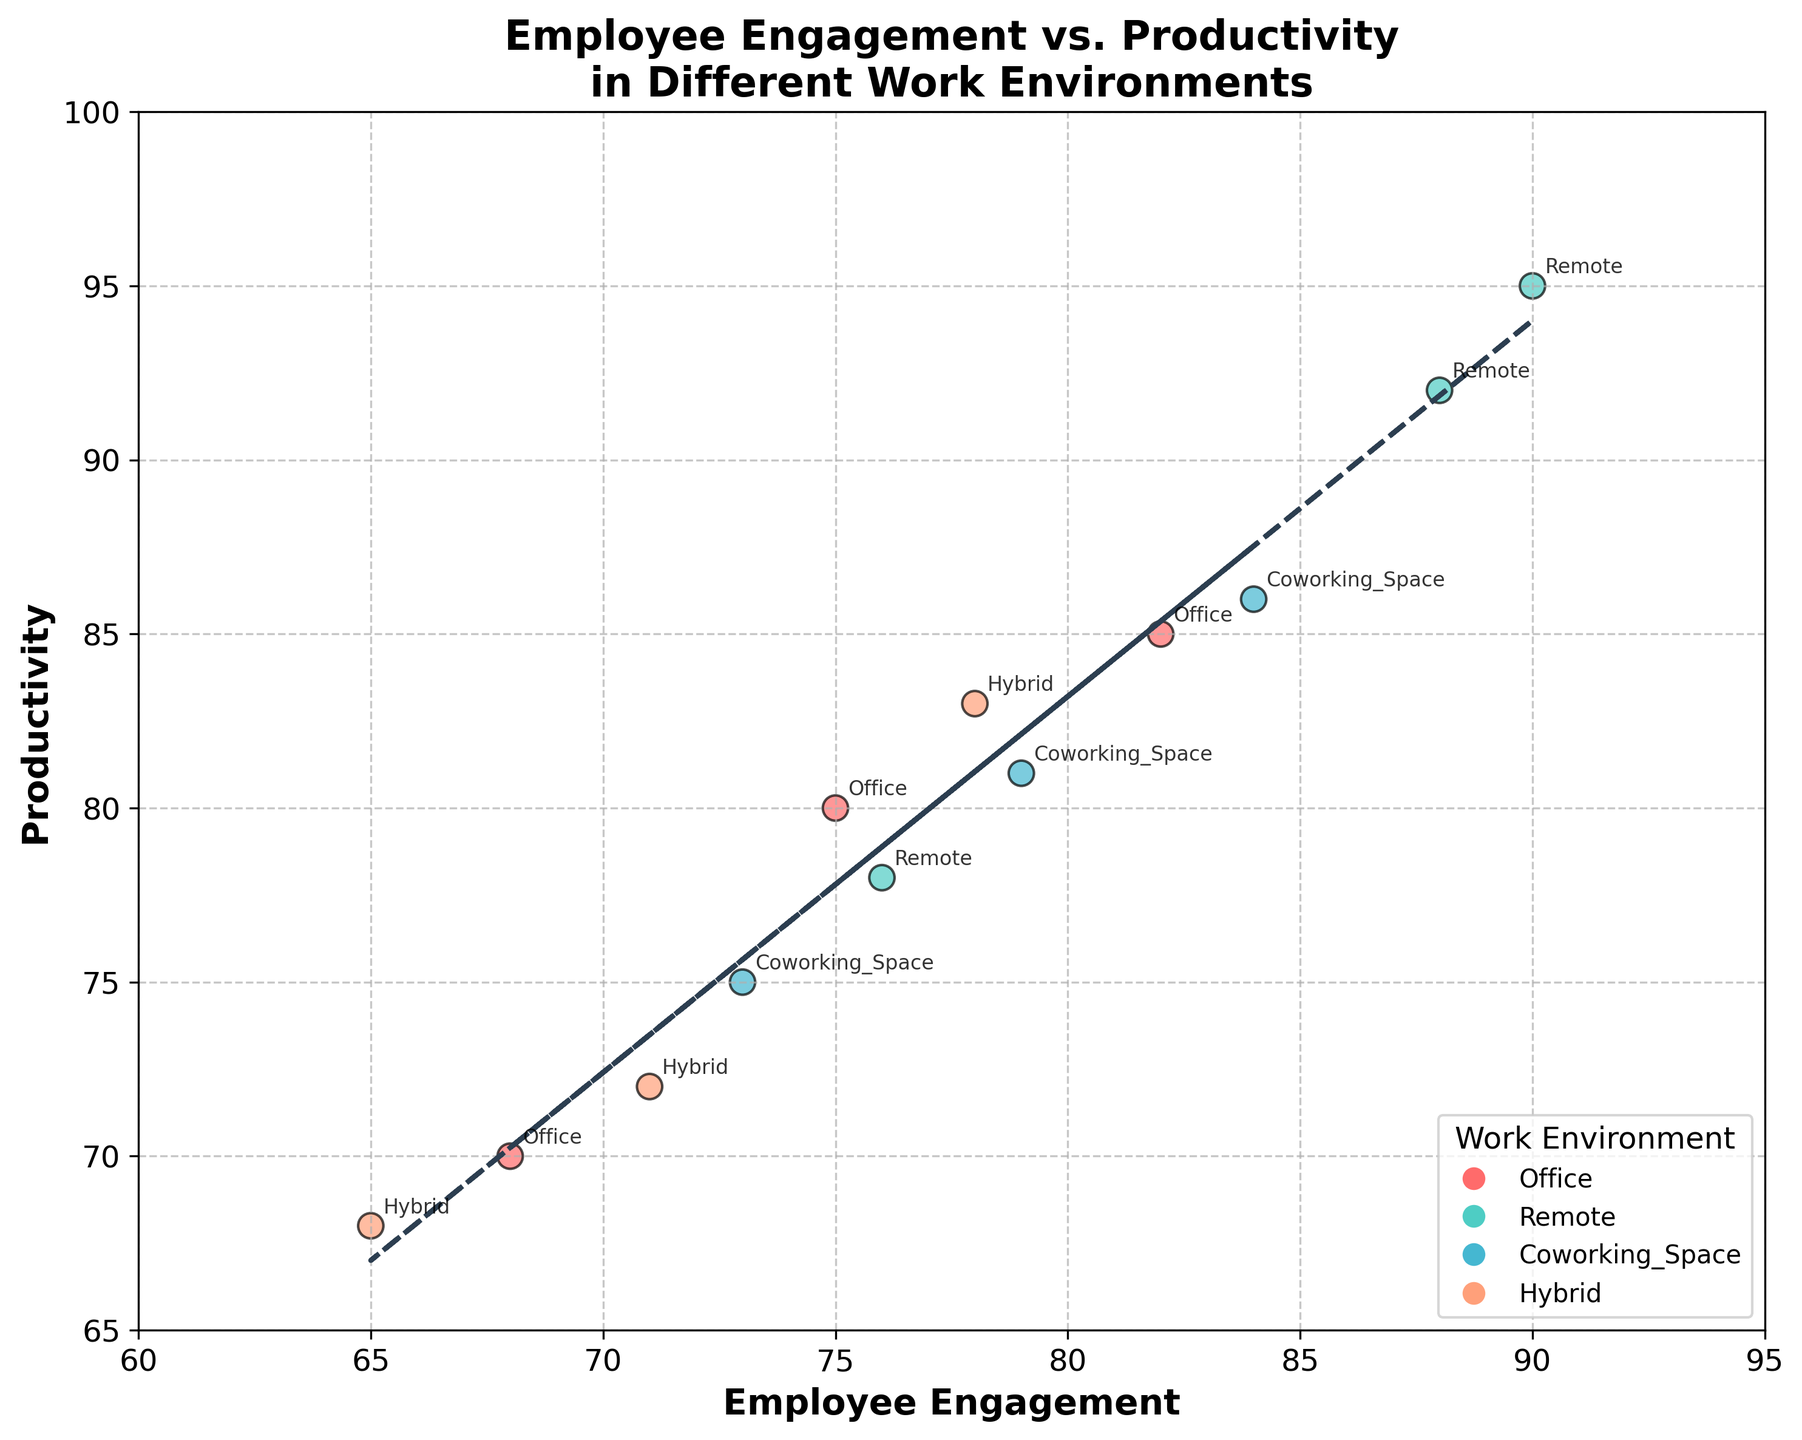What is the title of the scatter plot? The title of the scatter plot is displayed at the top of the figure and summarizes the main content of the plot.
Answer: Employee Engagement vs. Productivity in Different Work Environments Which axis represents Employee Engagement? The x-axis has the label 'Employee Engagement', indicating that it represents Employee Engagement values on the horizontal axis.
Answer: x-axis What is the color used for the 'Remote' work environment data points? By checking the legend at the bottom right of the figure, it indicates the color associated with each work environment. The 'Remote' category is shown with a greenish color.
Answer: greenish color How many data points are there for the 'Coworking_Space' environment? Each data point is labeled with its respective work environment annotation. By counting the labels 'Coworking_Space', we find there are three data points.
Answer: three What trend does the trend line indicate between Employee Engagement and Productivity? The trend line follows an upward slope, suggesting a positive correlation between Employee Engagement and Productivity.
Answer: positive correlation Compare the highest Productivity values between 'Office' and 'Remote' work environments. Which is higher? By observing the scatter points for each environment and identifying the highest points, the highest productivity values are: 'Office' (85) and 'Remote' (95). 95 is higher than 85.
Answer: Remote What is the range of Employee Engagement in the 'Hybrid' work environment? Observing the 'Hybrid' points, the Engaged values range from the minimum of 65 to the maximum of 78.
Answer: 65 to 78 Considering both Engagement and Productivity, which work environment appears to have the most balanced data points within the mid-range values (70-80)? By checking the scatter points distributed in the mid-range (70-80) for both axes, the 'Hybrid' and 'Office' environments have several points, but 'Office' seems more balanced with more points relatively close to one another.
Answer: Office Determine the average Productivity for the 'Coworking_Space' environment. Adding up the Productivity values for 'Coworking_Space': (86 + 81 + 75) and dividing by the number of points (3), we get (86 + 81 + 75) / 3 = 242 / 3 = 80.67
Answer: 80.67 